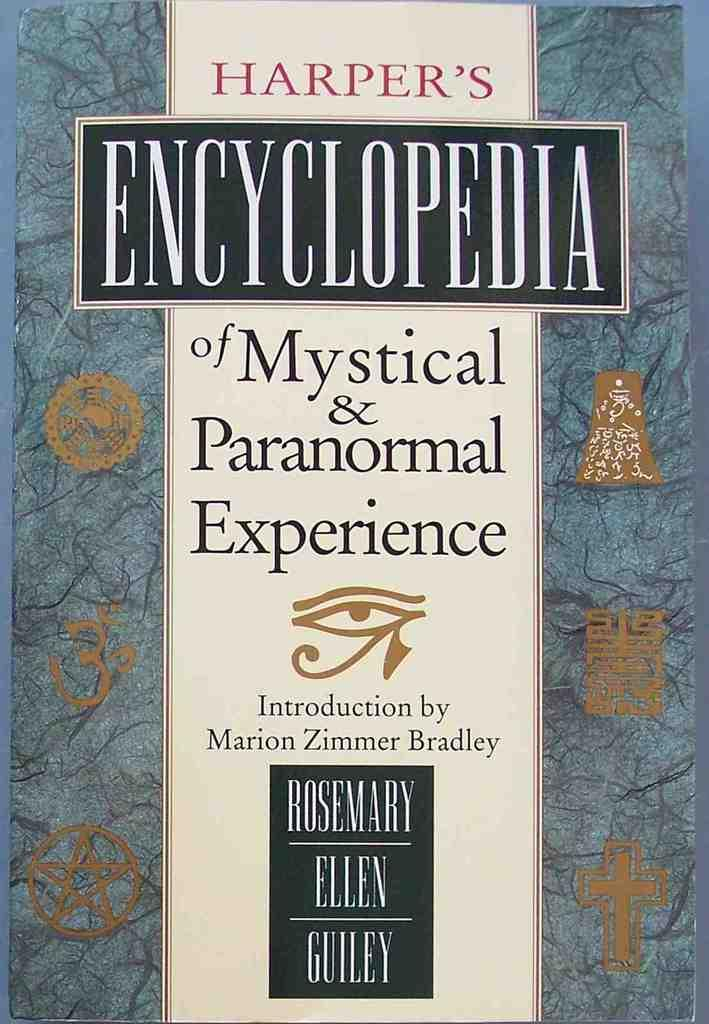<image>
Offer a succinct explanation of the picture presented. A Harper's encyclopedia has an introduction by Marion Zimmer Bradley. 